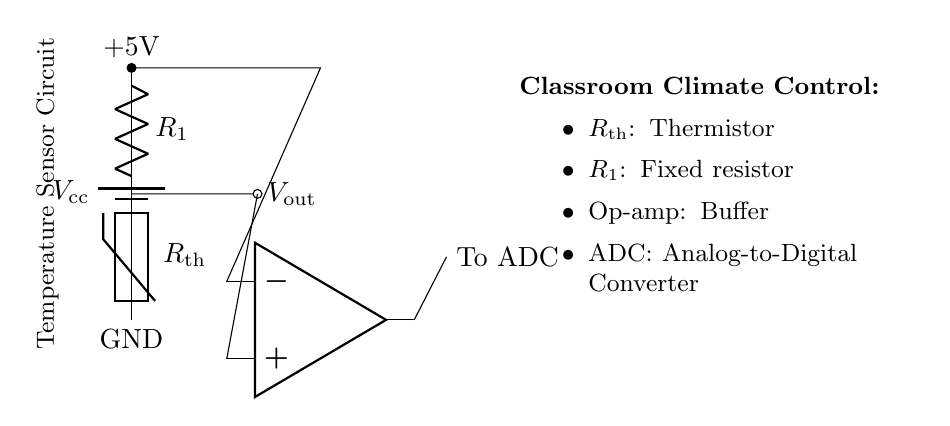What is the voltage supply in this circuit? The circuit is powered by a battery labeled as V_cc, which is indicated to provide a voltage of 5V.
Answer: 5V What type of resistor is used in this circuit? The circuit includes two types of resistors; a fixed resistor labeled R1 and a thermistor labeled R_th, which is a type of temperature-sensitive resistor.
Answer: Thermistor What is the purpose of the operational amplifier in this circuit? The operational amplifier (op-amp) in the diagram functions as a buffer to amplify the output voltage from the voltage divider formed by R1 and R_th.
Answer: Buffer How many components are connected to the voltage divider output? The voltage divider output connects to the operational amplifier as well as to a point marked 'To ADC', indicating an analog-to-digital converter connection; therefore, there are two active connections.
Answer: 2 What happens to the output voltage as the temperature increases? As the temperature increases, the resistance of the thermistor decreases, resulting in an increase in the output voltage, since it is part of a voltage divider with a fixed resistor.
Answer: Increases What does ADC stand for in this circuit? The acronym ADC stands for Analog-to-Digital Converter, which is used to convert the analog output voltage from the op-amp into a digital signal.
Answer: Analog-to-Digital Converter 